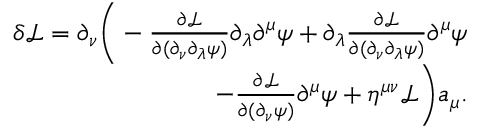Convert formula to latex. <formula><loc_0><loc_0><loc_500><loc_500>\begin{array} { r } { \delta \mathcal { L } = \partial _ { \nu } \left ( - \frac { \partial \mathcal { L } } { \partial ( \partial _ { \nu } \partial _ { \lambda } \psi ) } \partial _ { \lambda } \partial ^ { \mu } \psi + \partial _ { \lambda } \frac { \partial \mathcal { L } } { \partial ( \partial _ { \nu } \partial _ { \lambda } \psi ) } \partial ^ { \mu } \psi } \\ { - \frac { \partial \mathcal { L } } { \partial ( \partial _ { \nu } \psi ) } \partial ^ { \mu } \psi + \eta ^ { \mu \nu } \mathcal { L } \right ) a _ { \mu } . } \end{array}</formula> 